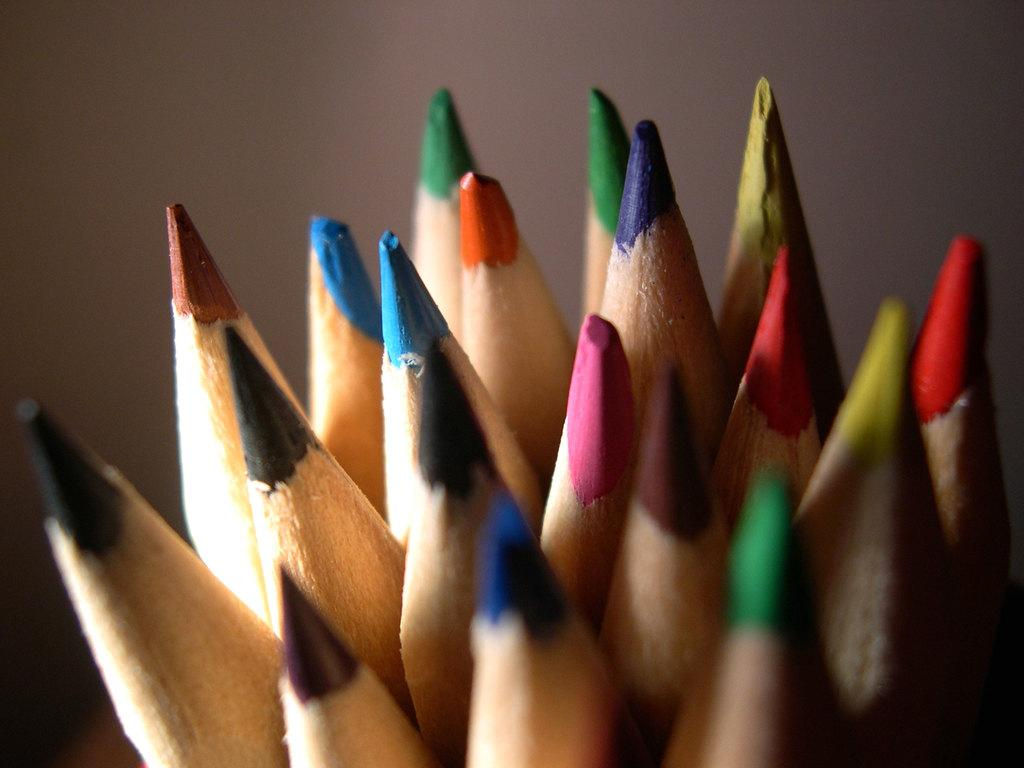What type of stationery items are present in the image? There are different color pencils in the image. Can you describe the shape of the pencils? The pencils are shaped. How does the giraffe attempt to use the beam in the image? There is no giraffe or beam present in the image; it only features different color pencils. 